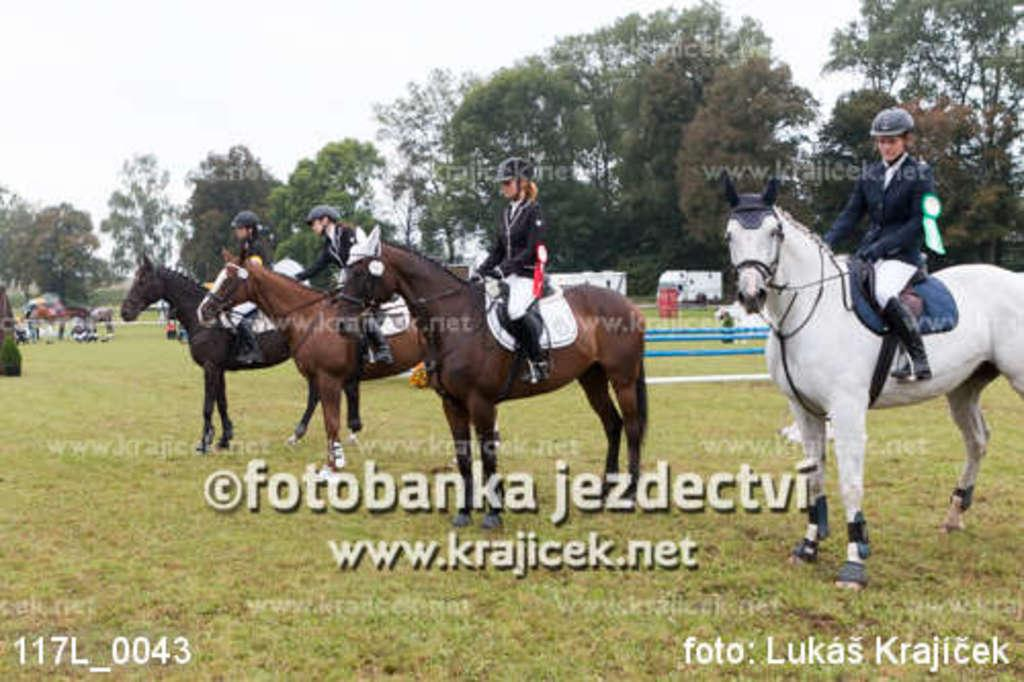How many people are in the image? There are four persons in the image. What are the people doing in the image? Each person is sitting on a horse. Can you describe the background of the image? There is a group of people, trees, and the sky visible in the background of the image. Are there any watermarks on the image? Yes, there are watermarks on the image. What type of music can be heard playing in the background of the image? There is no music present in the image, as it is a still photograph. How do the horses in the image express fear? The horses in the image do not express fear, as they are not depicted in any emotional state. 